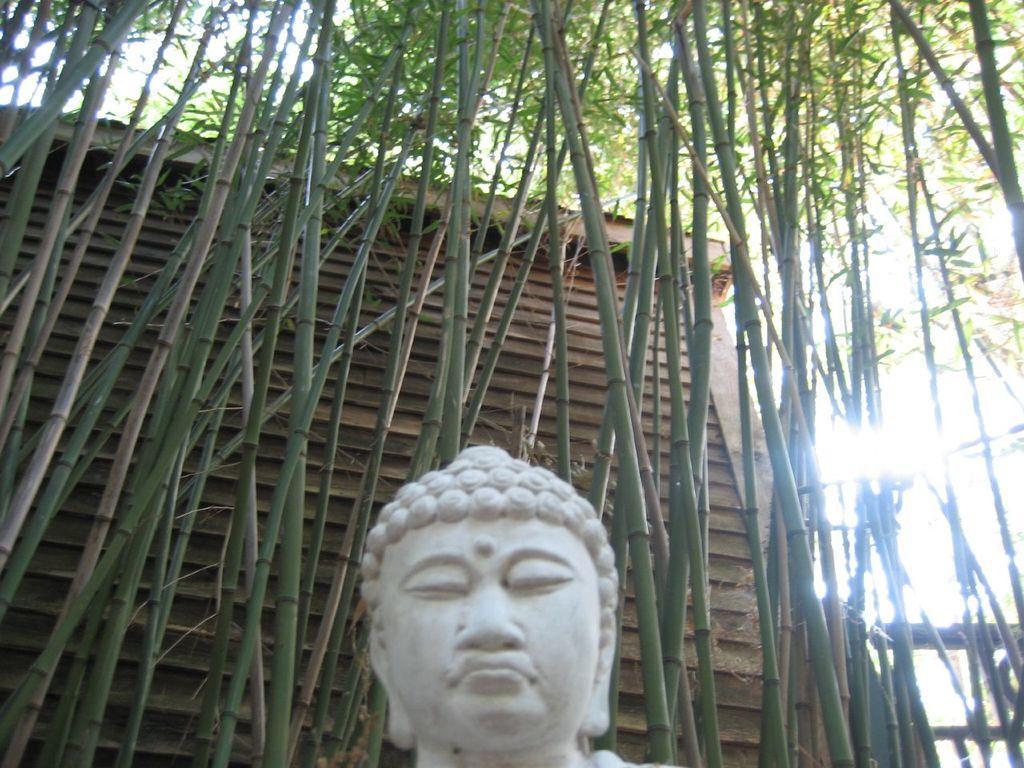Can you describe this image briefly? There is one statue is present at the bottom of this image. There are some bamboo trees in the background. 